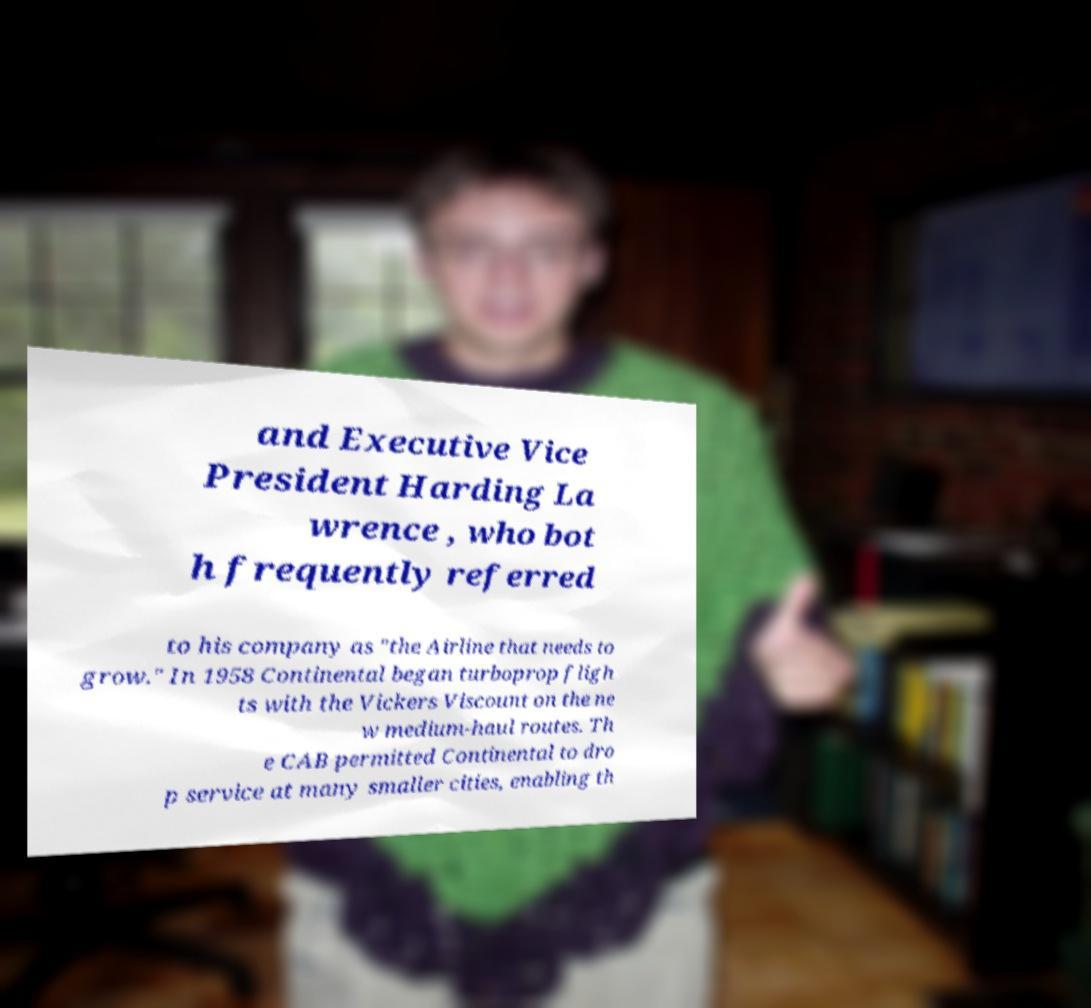Could you extract and type out the text from this image? and Executive Vice President Harding La wrence , who bot h frequently referred to his company as "the Airline that needs to grow." In 1958 Continental began turboprop fligh ts with the Vickers Viscount on the ne w medium-haul routes. Th e CAB permitted Continental to dro p service at many smaller cities, enabling th 